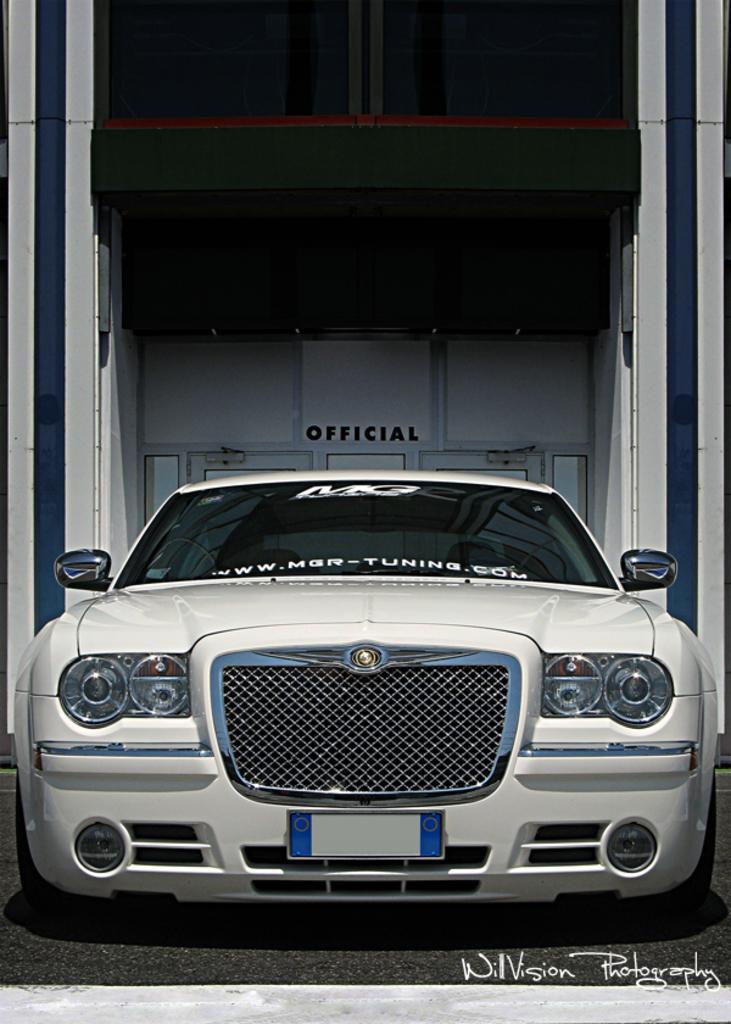In one or two sentences, can you explain what this image depicts? This is a picture consist of a white color car and there is a wall on the backside of the car. 